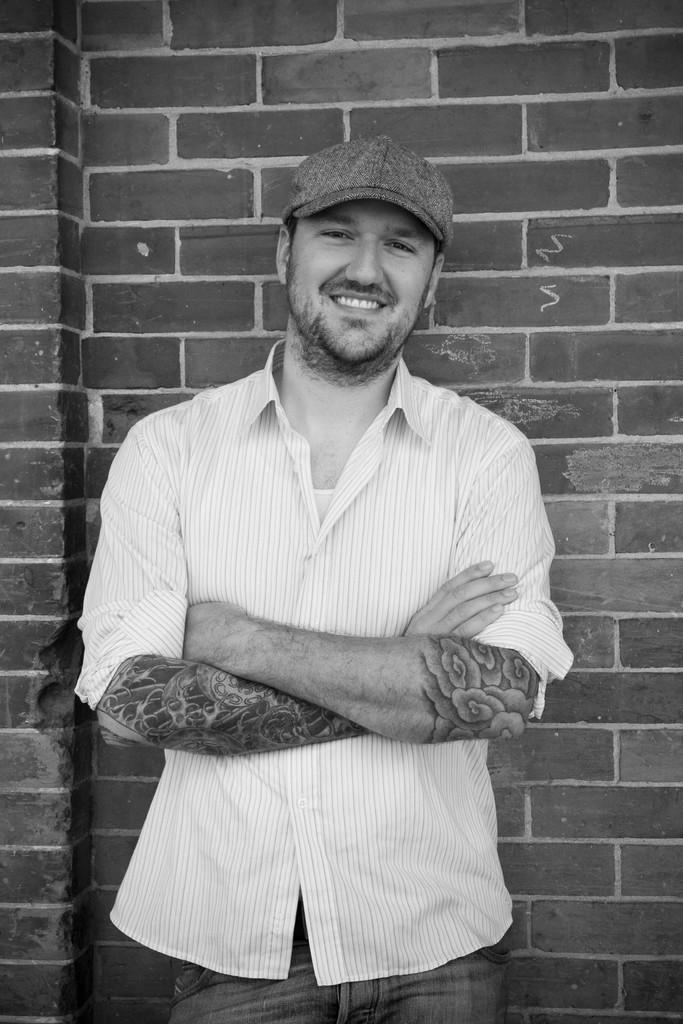What is the main subject of the image? The main subject of the image is a man. Can you describe the man's position in the image? The man is standing in the center of the image. What is the man's facial expression in the image? The man is smiling in the image. What can be seen in the background of the image? There is a wall in the background of the image. Can you tell me how many boys are present in the image? There is no boy present in the image; it features a man. What type of receipt can be seen in the man's hand in the image? There is no receipt visible in the man's hand or anywhere in the image. 